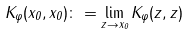Convert formula to latex. <formula><loc_0><loc_0><loc_500><loc_500>K _ { \varphi } ( x _ { 0 } , x _ { 0 } ) \colon = \lim _ { z \to x _ { 0 } } K _ { \varphi } ( z , z )</formula> 